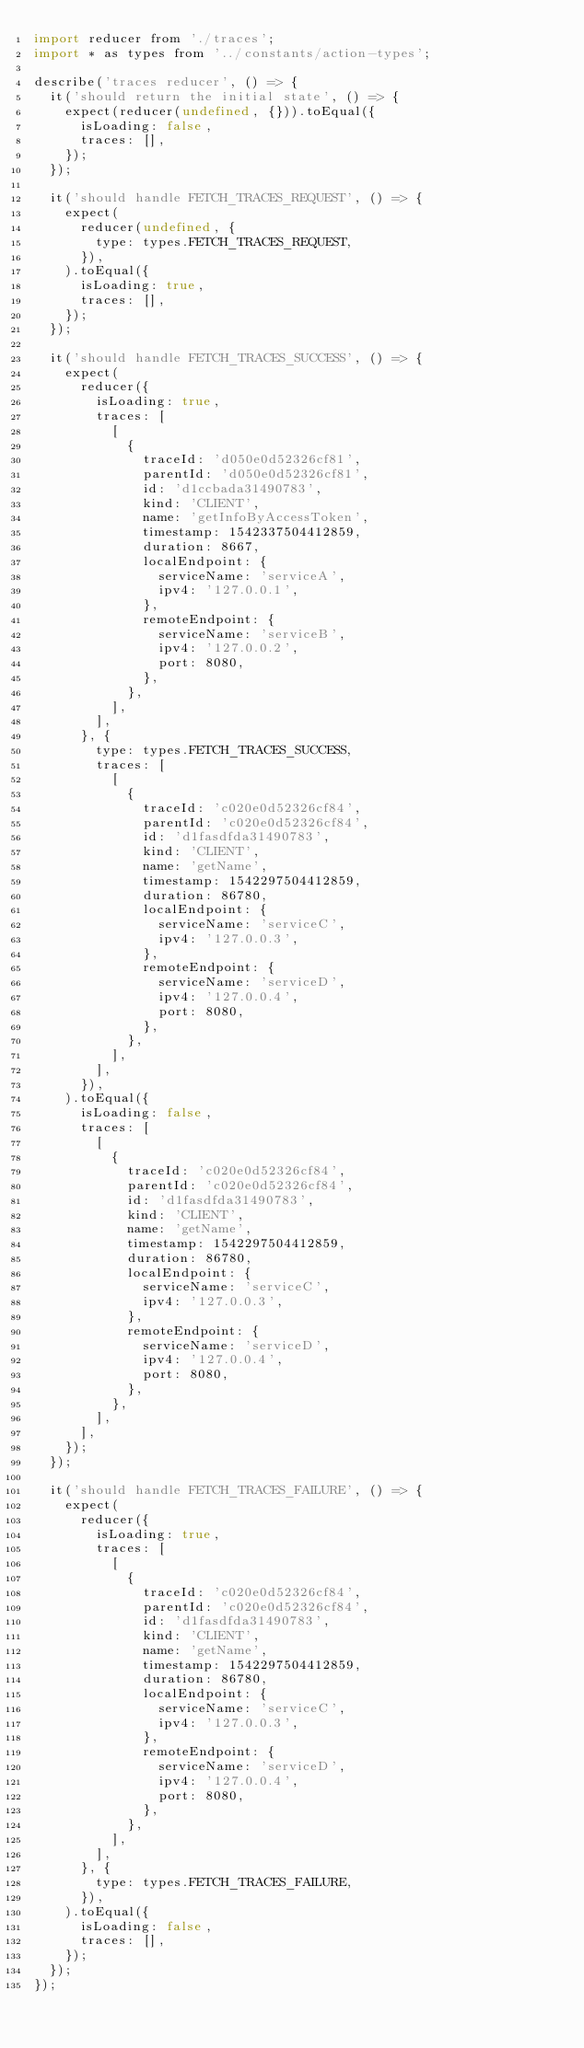<code> <loc_0><loc_0><loc_500><loc_500><_JavaScript_>import reducer from './traces';
import * as types from '../constants/action-types';

describe('traces reducer', () => {
  it('should return the initial state', () => {
    expect(reducer(undefined, {})).toEqual({
      isLoading: false,
      traces: [],
    });
  });

  it('should handle FETCH_TRACES_REQUEST', () => {
    expect(
      reducer(undefined, {
        type: types.FETCH_TRACES_REQUEST,
      }),
    ).toEqual({
      isLoading: true,
      traces: [],
    });
  });

  it('should handle FETCH_TRACES_SUCCESS', () => {
    expect(
      reducer({
        isLoading: true,
        traces: [
          [
            {
              traceId: 'd050e0d52326cf81',
              parentId: 'd050e0d52326cf81',
              id: 'd1ccbada31490783',
              kind: 'CLIENT',
              name: 'getInfoByAccessToken',
              timestamp: 1542337504412859,
              duration: 8667,
              localEndpoint: {
                serviceName: 'serviceA',
                ipv4: '127.0.0.1',
              },
              remoteEndpoint: {
                serviceName: 'serviceB',
                ipv4: '127.0.0.2',
                port: 8080,
              },
            },
          ],
        ],
      }, {
        type: types.FETCH_TRACES_SUCCESS,
        traces: [
          [
            {
              traceId: 'c020e0d52326cf84',
              parentId: 'c020e0d52326cf84',
              id: 'd1fasdfda31490783',
              kind: 'CLIENT',
              name: 'getName',
              timestamp: 1542297504412859,
              duration: 86780,
              localEndpoint: {
                serviceName: 'serviceC',
                ipv4: '127.0.0.3',
              },
              remoteEndpoint: {
                serviceName: 'serviceD',
                ipv4: '127.0.0.4',
                port: 8080,
              },
            },
          ],
        ],
      }),
    ).toEqual({
      isLoading: false,
      traces: [
        [
          {
            traceId: 'c020e0d52326cf84',
            parentId: 'c020e0d52326cf84',
            id: 'd1fasdfda31490783',
            kind: 'CLIENT',
            name: 'getName',
            timestamp: 1542297504412859,
            duration: 86780,
            localEndpoint: {
              serviceName: 'serviceC',
              ipv4: '127.0.0.3',
            },
            remoteEndpoint: {
              serviceName: 'serviceD',
              ipv4: '127.0.0.4',
              port: 8080,
            },
          },
        ],
      ],
    });
  });

  it('should handle FETCH_TRACES_FAILURE', () => {
    expect(
      reducer({
        isLoading: true,
        traces: [
          [
            {
              traceId: 'c020e0d52326cf84',
              parentId: 'c020e0d52326cf84',
              id: 'd1fasdfda31490783',
              kind: 'CLIENT',
              name: 'getName',
              timestamp: 1542297504412859,
              duration: 86780,
              localEndpoint: {
                serviceName: 'serviceC',
                ipv4: '127.0.0.3',
              },
              remoteEndpoint: {
                serviceName: 'serviceD',
                ipv4: '127.0.0.4',
                port: 8080,
              },
            },
          ],
        ],
      }, {
        type: types.FETCH_TRACES_FAILURE,
      }),
    ).toEqual({
      isLoading: false,
      traces: [],
    });
  });
});
</code> 